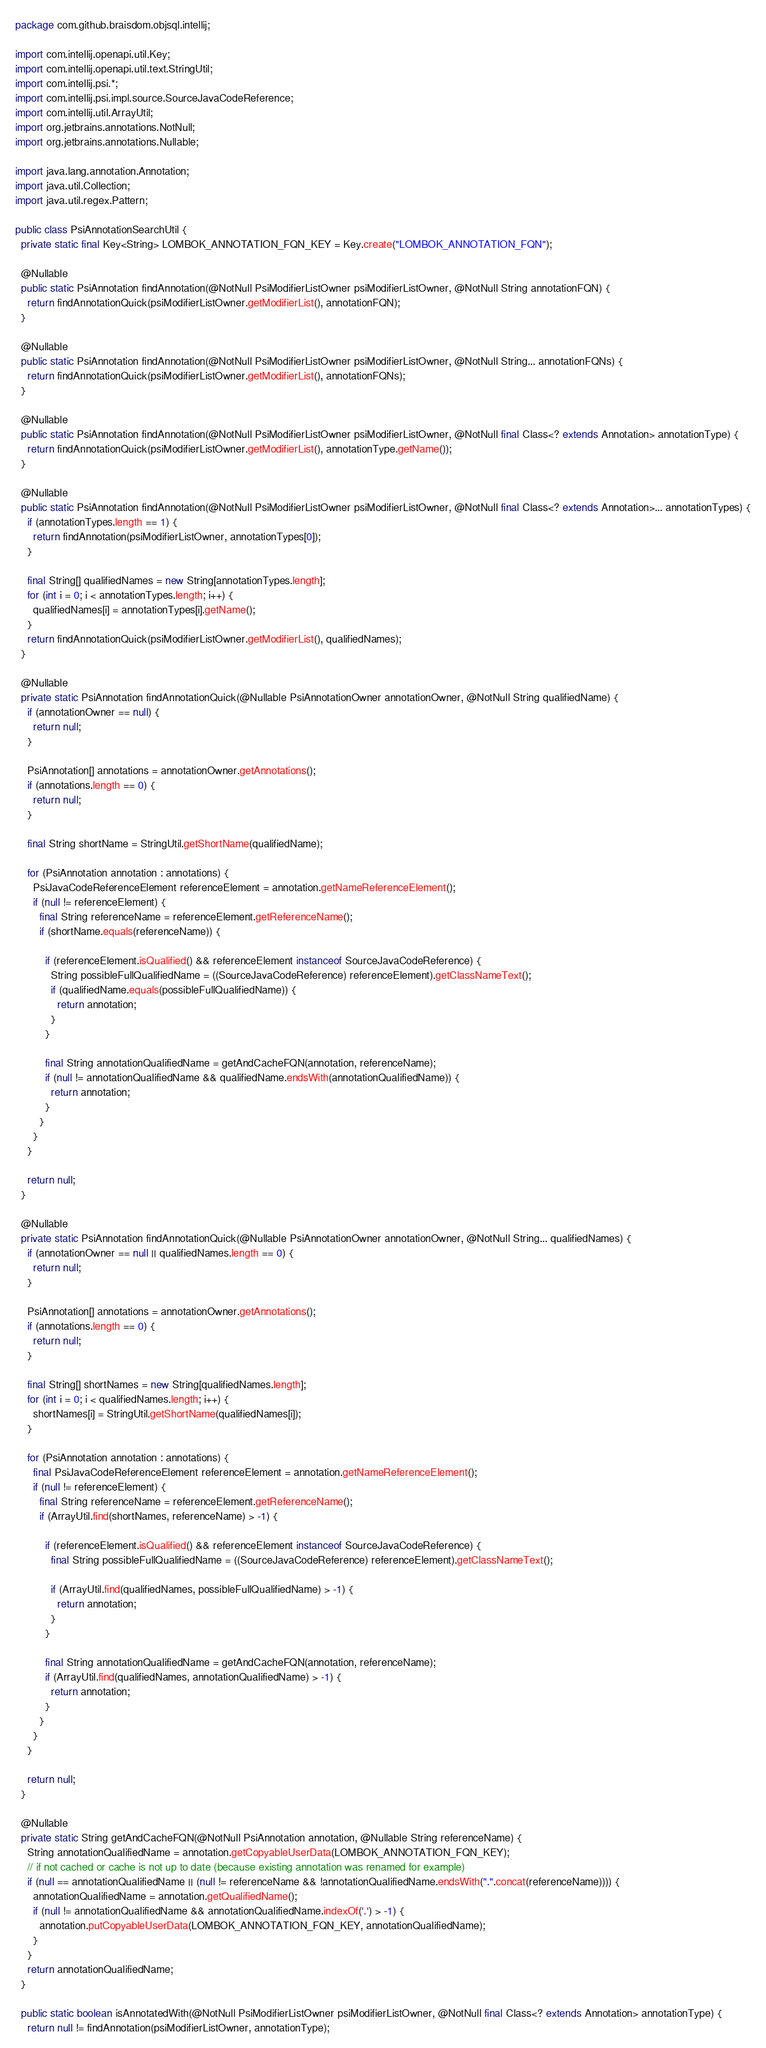<code> <loc_0><loc_0><loc_500><loc_500><_Java_>package com.github.braisdom.objsql.intellij;

import com.intellij.openapi.util.Key;
import com.intellij.openapi.util.text.StringUtil;
import com.intellij.psi.*;
import com.intellij.psi.impl.source.SourceJavaCodeReference;
import com.intellij.util.ArrayUtil;
import org.jetbrains.annotations.NotNull;
import org.jetbrains.annotations.Nullable;

import java.lang.annotation.Annotation;
import java.util.Collection;
import java.util.regex.Pattern;

public class PsiAnnotationSearchUtil {
  private static final Key<String> LOMBOK_ANNOTATION_FQN_KEY = Key.create("LOMBOK_ANNOTATION_FQN");

  @Nullable
  public static PsiAnnotation findAnnotation(@NotNull PsiModifierListOwner psiModifierListOwner, @NotNull String annotationFQN) {
    return findAnnotationQuick(psiModifierListOwner.getModifierList(), annotationFQN);
  }

  @Nullable
  public static PsiAnnotation findAnnotation(@NotNull PsiModifierListOwner psiModifierListOwner, @NotNull String... annotationFQNs) {
    return findAnnotationQuick(psiModifierListOwner.getModifierList(), annotationFQNs);
  }

  @Nullable
  public static PsiAnnotation findAnnotation(@NotNull PsiModifierListOwner psiModifierListOwner, @NotNull final Class<? extends Annotation> annotationType) {
    return findAnnotationQuick(psiModifierListOwner.getModifierList(), annotationType.getName());
  }

  @Nullable
  public static PsiAnnotation findAnnotation(@NotNull PsiModifierListOwner psiModifierListOwner, @NotNull final Class<? extends Annotation>... annotationTypes) {
    if (annotationTypes.length == 1) {
      return findAnnotation(psiModifierListOwner, annotationTypes[0]);
    }

    final String[] qualifiedNames = new String[annotationTypes.length];
    for (int i = 0; i < annotationTypes.length; i++) {
      qualifiedNames[i] = annotationTypes[i].getName();
    }
    return findAnnotationQuick(psiModifierListOwner.getModifierList(), qualifiedNames);
  }

  @Nullable
  private static PsiAnnotation findAnnotationQuick(@Nullable PsiAnnotationOwner annotationOwner, @NotNull String qualifiedName) {
    if (annotationOwner == null) {
      return null;
    }

    PsiAnnotation[] annotations = annotationOwner.getAnnotations();
    if (annotations.length == 0) {
      return null;
    }

    final String shortName = StringUtil.getShortName(qualifiedName);

    for (PsiAnnotation annotation : annotations) {
      PsiJavaCodeReferenceElement referenceElement = annotation.getNameReferenceElement();
      if (null != referenceElement) {
        final String referenceName = referenceElement.getReferenceName();
        if (shortName.equals(referenceName)) {

          if (referenceElement.isQualified() && referenceElement instanceof SourceJavaCodeReference) {
            String possibleFullQualifiedName = ((SourceJavaCodeReference) referenceElement).getClassNameText();
            if (qualifiedName.equals(possibleFullQualifiedName)) {
              return annotation;
            }
          }

          final String annotationQualifiedName = getAndCacheFQN(annotation, referenceName);
          if (null != annotationQualifiedName && qualifiedName.endsWith(annotationQualifiedName)) {
            return annotation;
          }
        }
      }
    }

    return null;
  }

  @Nullable
  private static PsiAnnotation findAnnotationQuick(@Nullable PsiAnnotationOwner annotationOwner, @NotNull String... qualifiedNames) {
    if (annotationOwner == null || qualifiedNames.length == 0) {
      return null;
    }

    PsiAnnotation[] annotations = annotationOwner.getAnnotations();
    if (annotations.length == 0) {
      return null;
    }

    final String[] shortNames = new String[qualifiedNames.length];
    for (int i = 0; i < qualifiedNames.length; i++) {
      shortNames[i] = StringUtil.getShortName(qualifiedNames[i]);
    }

    for (PsiAnnotation annotation : annotations) {
      final PsiJavaCodeReferenceElement referenceElement = annotation.getNameReferenceElement();
      if (null != referenceElement) {
        final String referenceName = referenceElement.getReferenceName();
        if (ArrayUtil.find(shortNames, referenceName) > -1) {

          if (referenceElement.isQualified() && referenceElement instanceof SourceJavaCodeReference) {
            final String possibleFullQualifiedName = ((SourceJavaCodeReference) referenceElement).getClassNameText();

            if (ArrayUtil.find(qualifiedNames, possibleFullQualifiedName) > -1) {
              return annotation;
            }
          }

          final String annotationQualifiedName = getAndCacheFQN(annotation, referenceName);
          if (ArrayUtil.find(qualifiedNames, annotationQualifiedName) > -1) {
            return annotation;
          }
        }
      }
    }

    return null;
  }

  @Nullable
  private static String getAndCacheFQN(@NotNull PsiAnnotation annotation, @Nullable String referenceName) {
    String annotationQualifiedName = annotation.getCopyableUserData(LOMBOK_ANNOTATION_FQN_KEY);
    // if not cached or cache is not up to date (because existing annotation was renamed for example)
    if (null == annotationQualifiedName || (null != referenceName && !annotationQualifiedName.endsWith(".".concat(referenceName)))) {
      annotationQualifiedName = annotation.getQualifiedName();
      if (null != annotationQualifiedName && annotationQualifiedName.indexOf('.') > -1) {
        annotation.putCopyableUserData(LOMBOK_ANNOTATION_FQN_KEY, annotationQualifiedName);
      }
    }
    return annotationQualifiedName;
  }

  public static boolean isAnnotatedWith(@NotNull PsiModifierListOwner psiModifierListOwner, @NotNull final Class<? extends Annotation> annotationType) {
    return null != findAnnotation(psiModifierListOwner, annotationType);</code> 